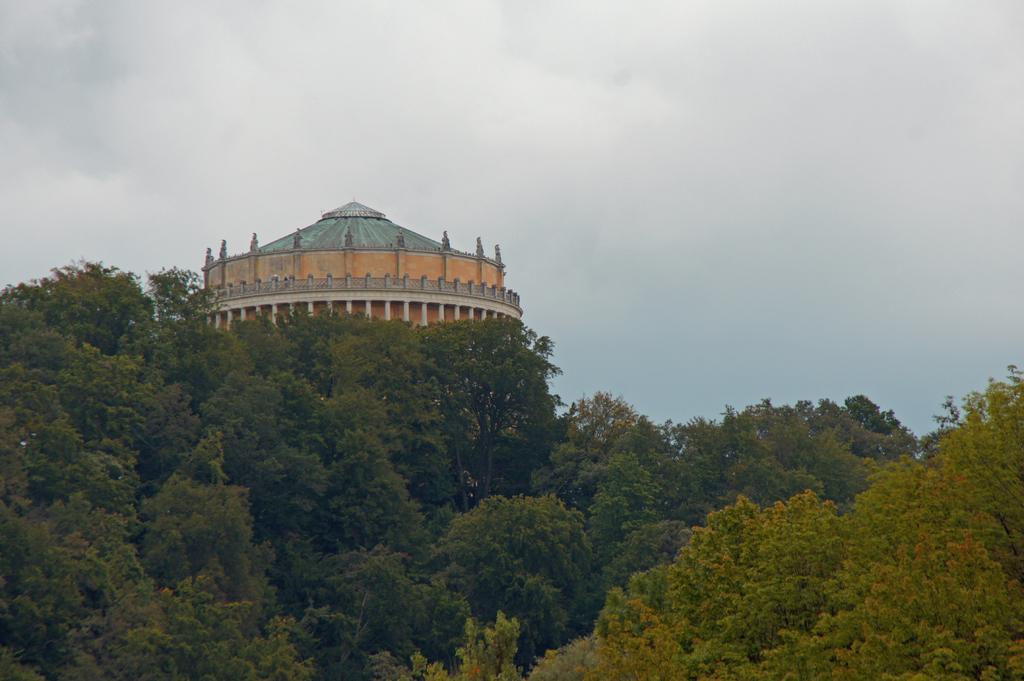Describe this image in one or two sentences. Trees are present at the bottom of this image and there is a water tower in the background. There is a sky at the top of this image. 